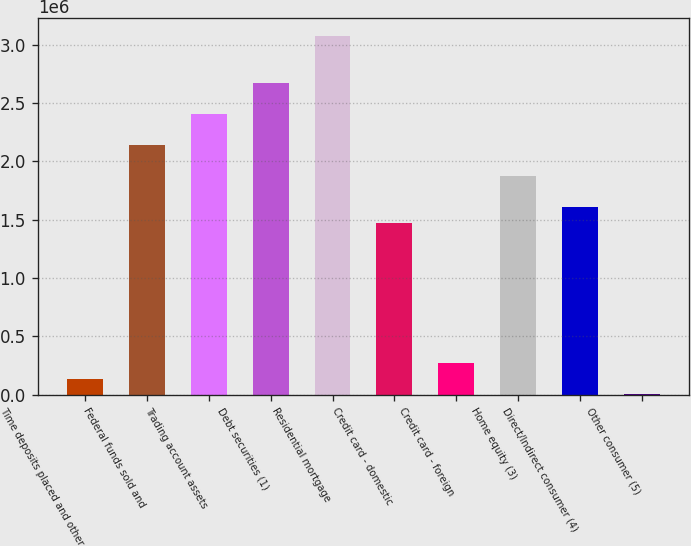Convert chart. <chart><loc_0><loc_0><loc_500><loc_500><bar_chart><fcel>Time deposits placed and other<fcel>Federal funds sold and<fcel>Trading account assets<fcel>Debt securities (1)<fcel>Residential mortgage<fcel>Credit card - domestic<fcel>Credit card - foreign<fcel>Home equity (3)<fcel>Direct/Indirect consumer (4)<fcel>Other consumer (5)<nl><fcel>137499<fcel>2.14122e+06<fcel>2.40838e+06<fcel>2.67554e+06<fcel>3.07629e+06<fcel>1.47331e+06<fcel>271081<fcel>1.87406e+06<fcel>1.60689e+06<fcel>3918<nl></chart> 